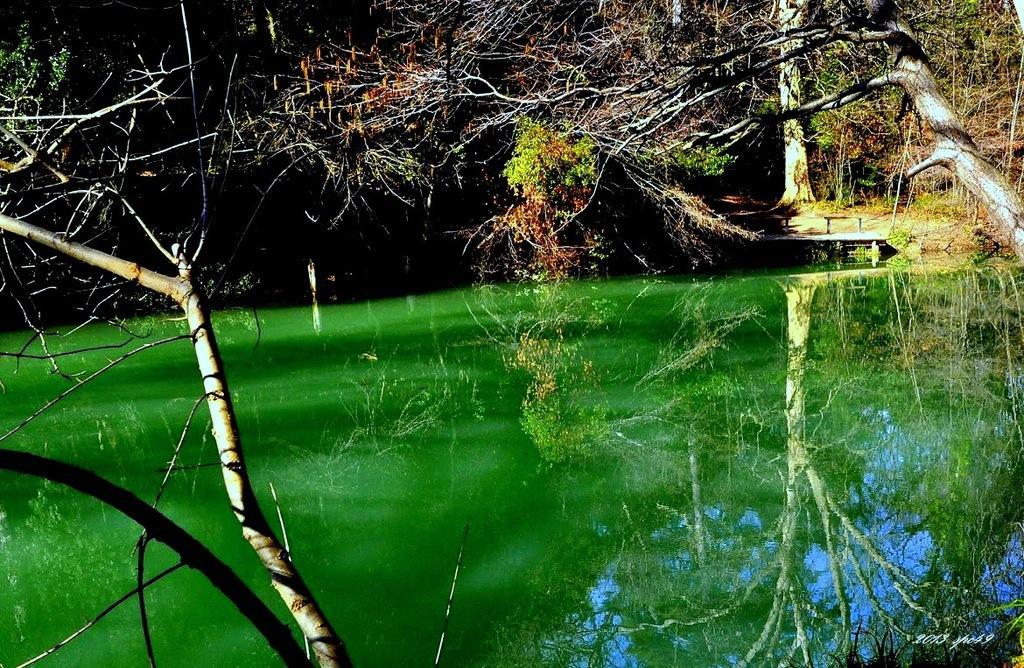Could you give a brief overview of what you see in this image? In this image we can see some trees, plants and other objects. At the bottom of the image there is water. On the water we can see some reflections. On the left and the right side of the image we can see a tree. On the image there is a watermark. 